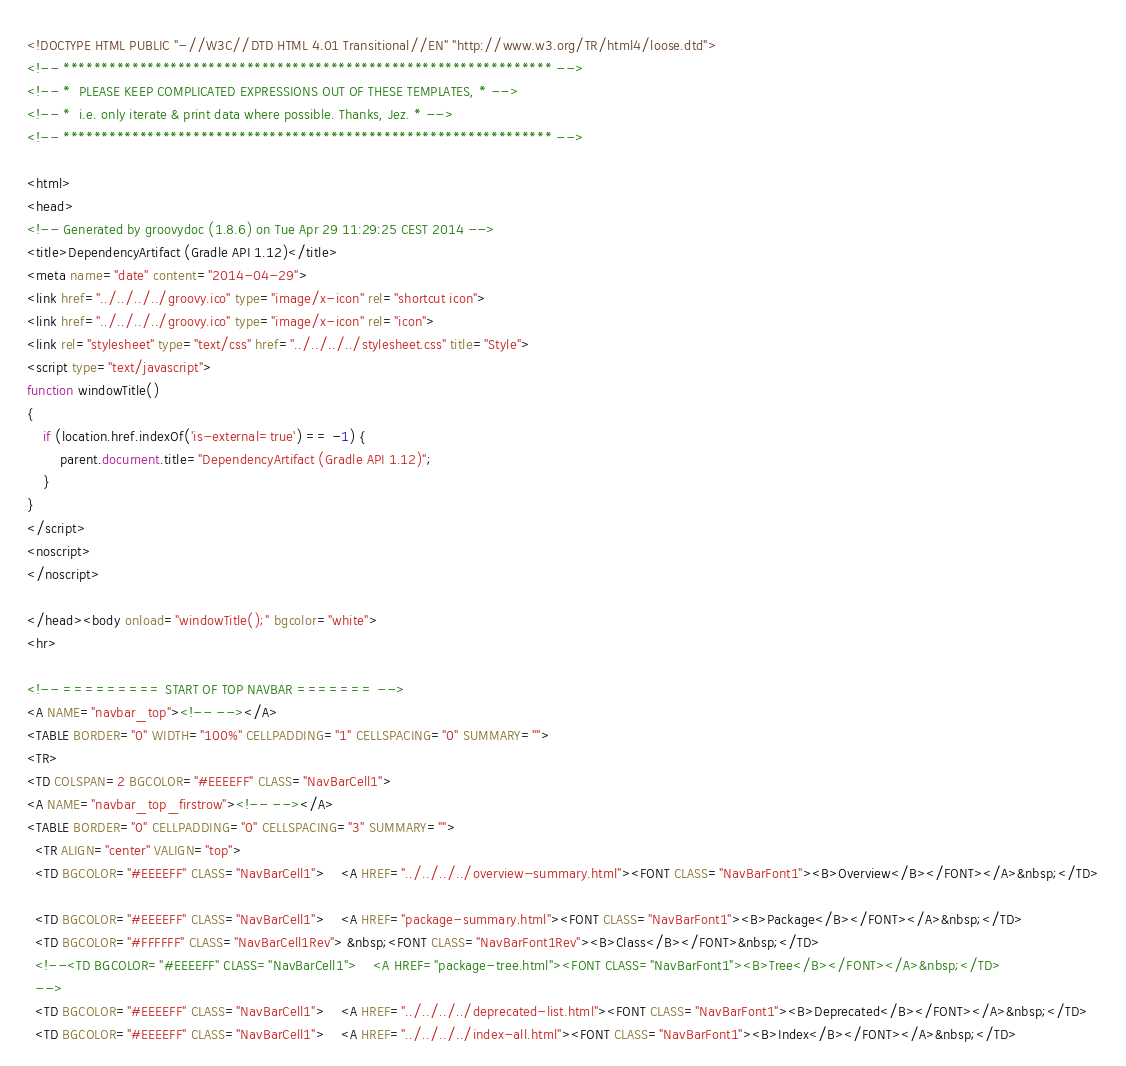<code> <loc_0><loc_0><loc_500><loc_500><_HTML_><!DOCTYPE HTML PUBLIC "-//W3C//DTD HTML 4.01 Transitional//EN" "http://www.w3.org/TR/html4/loose.dtd">
<!-- **************************************************************** -->
<!-- *  PLEASE KEEP COMPLICATED EXPRESSIONS OUT OF THESE TEMPLATES, * -->
<!-- *  i.e. only iterate & print data where possible. Thanks, Jez. * -->
<!-- **************************************************************** -->

<html>
<head>
<!-- Generated by groovydoc (1.8.6) on Tue Apr 29 11:29:25 CEST 2014 -->
<title>DependencyArtifact (Gradle API 1.12)</title>
<meta name="date" content="2014-04-29">
<link href="../../../../groovy.ico" type="image/x-icon" rel="shortcut icon">
<link href="../../../../groovy.ico" type="image/x-icon" rel="icon">
<link rel="stylesheet" type="text/css" href="../../../../stylesheet.css" title="Style">
<script type="text/javascript">
function windowTitle()
{
    if (location.href.indexOf('is-external=true') == -1) {
        parent.document.title="DependencyArtifact (Gradle API 1.12)";
    }
}
</script>
<noscript>
</noscript>

</head><body onload="windowTitle();" bgcolor="white">
<hr>

<!-- ========= START OF TOP NAVBAR ======= -->
<A NAME="navbar_top"><!-- --></A>
<TABLE BORDER="0" WIDTH="100%" CELLPADDING="1" CELLSPACING="0" SUMMARY="">
<TR>
<TD COLSPAN=2 BGCOLOR="#EEEEFF" CLASS="NavBarCell1">
<A NAME="navbar_top_firstrow"><!-- --></A>
<TABLE BORDER="0" CELLPADDING="0" CELLSPACING="3" SUMMARY="">
  <TR ALIGN="center" VALIGN="top">
  <TD BGCOLOR="#EEEEFF" CLASS="NavBarCell1">    <A HREF="../../../../overview-summary.html"><FONT CLASS="NavBarFont1"><B>Overview</B></FONT></A>&nbsp;</TD>

  <TD BGCOLOR="#EEEEFF" CLASS="NavBarCell1">    <A HREF="package-summary.html"><FONT CLASS="NavBarFont1"><B>Package</B></FONT></A>&nbsp;</TD>
  <TD BGCOLOR="#FFFFFF" CLASS="NavBarCell1Rev"> &nbsp;<FONT CLASS="NavBarFont1Rev"><B>Class</B></FONT>&nbsp;</TD>
  <!--<TD BGCOLOR="#EEEEFF" CLASS="NavBarCell1">    <A HREF="package-tree.html"><FONT CLASS="NavBarFont1"><B>Tree</B></FONT></A>&nbsp;</TD>
  -->
  <TD BGCOLOR="#EEEEFF" CLASS="NavBarCell1">    <A HREF="../../../../deprecated-list.html"><FONT CLASS="NavBarFont1"><B>Deprecated</B></FONT></A>&nbsp;</TD>
  <TD BGCOLOR="#EEEEFF" CLASS="NavBarCell1">    <A HREF="../../../../index-all.html"><FONT CLASS="NavBarFont1"><B>Index</B></FONT></A>&nbsp;</TD></code> 